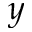Convert formula to latex. <formula><loc_0><loc_0><loc_500><loc_500>y</formula> 